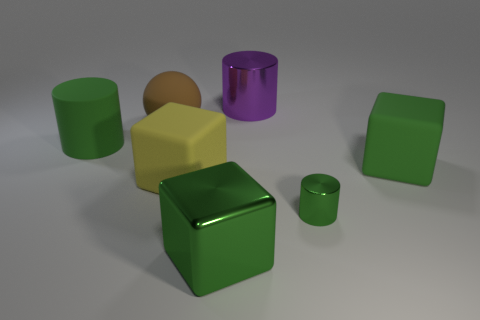What number of big objects are either green shiny cubes or balls?
Your answer should be very brief. 2. Does the yellow matte object have the same size as the metal cylinder that is behind the brown matte object?
Ensure brevity in your answer.  Yes. Is there anything else that is the same shape as the purple metal object?
Your answer should be compact. Yes. What number of big objects are there?
Ensure brevity in your answer.  6. How many green things are blocks or small cylinders?
Give a very brief answer. 3. Are the big cylinder that is left of the big purple metal cylinder and the big yellow cube made of the same material?
Offer a terse response. Yes. What number of other objects are the same material as the tiny green cylinder?
Offer a very short reply. 2. What material is the purple cylinder?
Keep it short and to the point. Metal. What is the size of the matte object that is left of the big sphere?
Offer a very short reply. Large. There is a cylinder to the left of the metallic block; what number of big purple metal cylinders are behind it?
Provide a succinct answer. 1. 